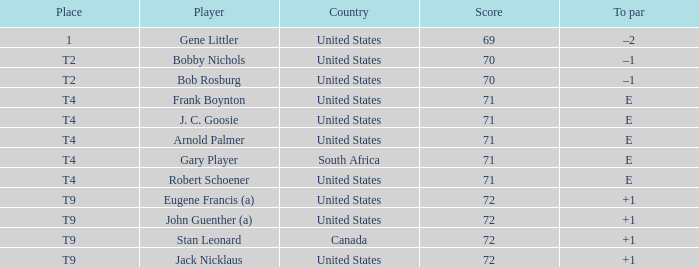What is To Par, when Country is "United States", when Place is "T4", and when Player is "Frank Boynton"? E. 